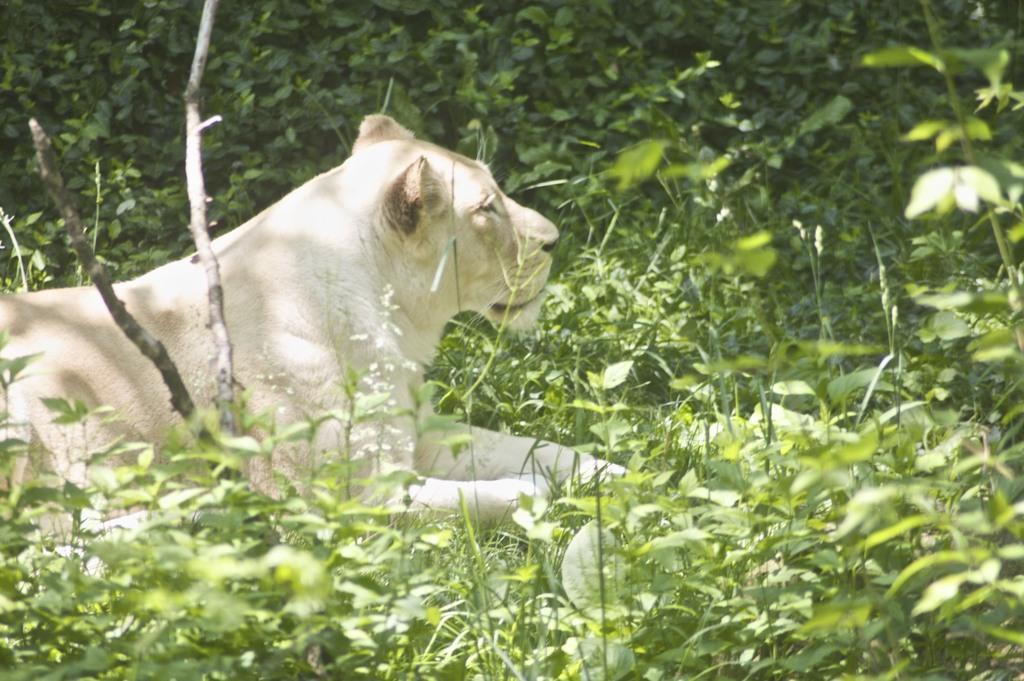Please provide a concise description of this image. In this image there are plants and in the center there is an animal sitting. 